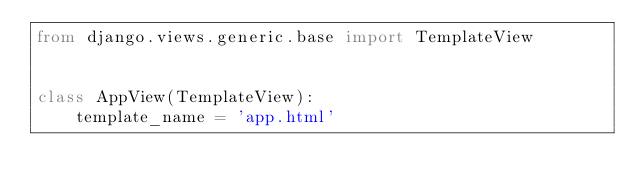Convert code to text. <code><loc_0><loc_0><loc_500><loc_500><_Python_>from django.views.generic.base import TemplateView


class AppView(TemplateView):
    template_name = 'app.html'
</code> 